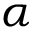Convert formula to latex. <formula><loc_0><loc_0><loc_500><loc_500>\alpha</formula> 